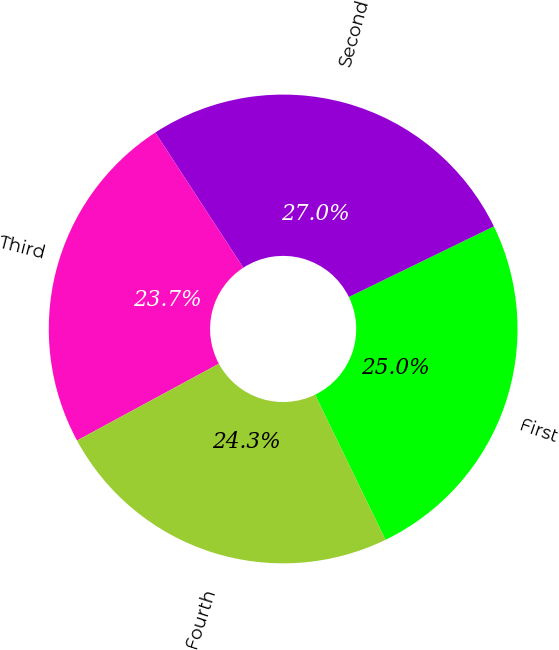<chart> <loc_0><loc_0><loc_500><loc_500><pie_chart><fcel>First<fcel>Second<fcel>Third<fcel>Fourth<nl><fcel>25.02%<fcel>26.97%<fcel>23.71%<fcel>24.29%<nl></chart> 